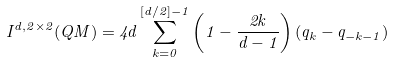Convert formula to latex. <formula><loc_0><loc_0><loc_500><loc_500>I ^ { d , 2 \times 2 } ( Q M ) = 4 d \sum _ { k = 0 } ^ { [ d / 2 ] - 1 } \left ( 1 - \frac { 2 k } { d - 1 } \right ) ( q _ { k } - q _ { - k - 1 } )</formula> 